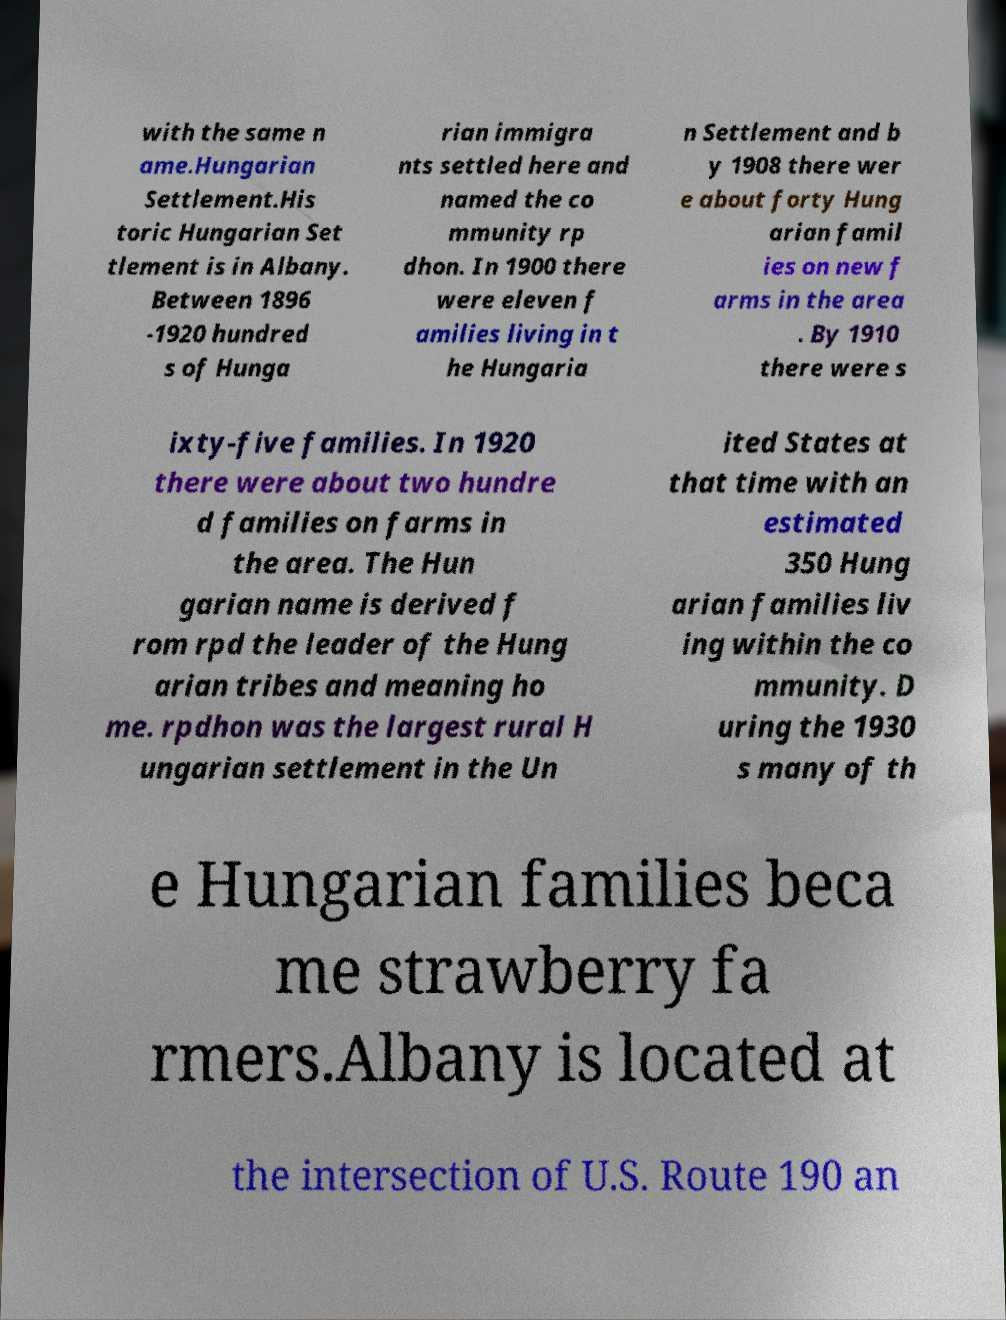What messages or text are displayed in this image? I need them in a readable, typed format. with the same n ame.Hungarian Settlement.His toric Hungarian Set tlement is in Albany. Between 1896 -1920 hundred s of Hunga rian immigra nts settled here and named the co mmunity rp dhon. In 1900 there were eleven f amilies living in t he Hungaria n Settlement and b y 1908 there wer e about forty Hung arian famil ies on new f arms in the area . By 1910 there were s ixty-five families. In 1920 there were about two hundre d families on farms in the area. The Hun garian name is derived f rom rpd the leader of the Hung arian tribes and meaning ho me. rpdhon was the largest rural H ungarian settlement in the Un ited States at that time with an estimated 350 Hung arian families liv ing within the co mmunity. D uring the 1930 s many of th e Hungarian families beca me strawberry fa rmers.Albany is located at the intersection of U.S. Route 190 an 